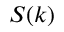Convert formula to latex. <formula><loc_0><loc_0><loc_500><loc_500>S ( k )</formula> 